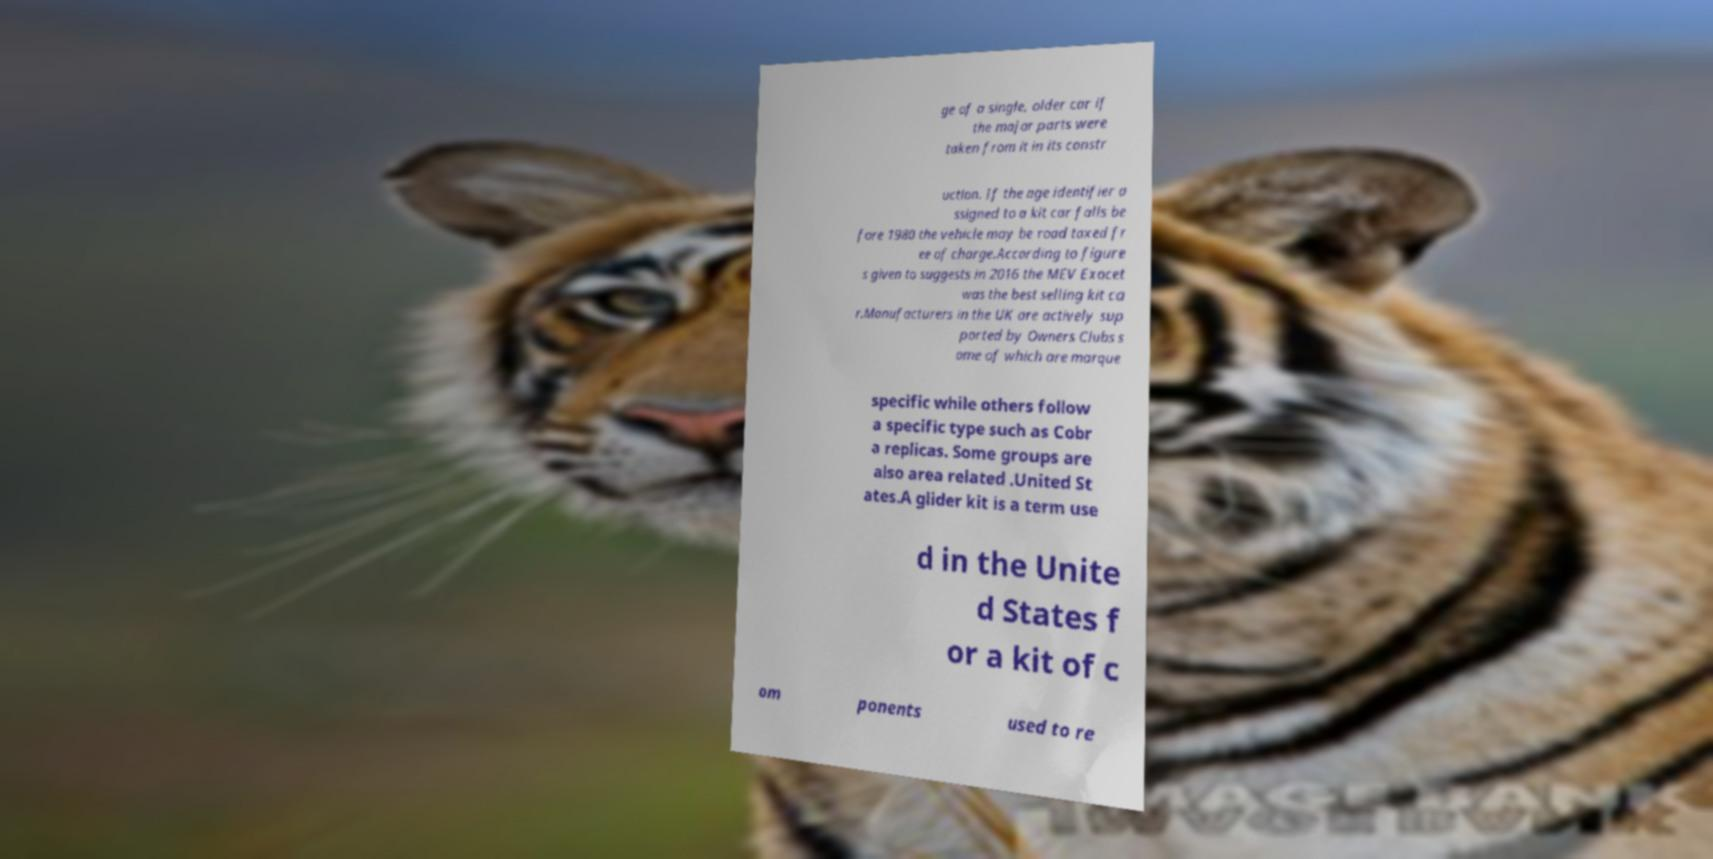What messages or text are displayed in this image? I need them in a readable, typed format. ge of a single, older car if the major parts were taken from it in its constr uction. If the age identifier a ssigned to a kit car falls be fore 1980 the vehicle may be road taxed fr ee of charge.According to figure s given to suggests in 2016 the MEV Exocet was the best selling kit ca r.Manufacturers in the UK are actively sup ported by Owners Clubs s ome of which are marque specific while others follow a specific type such as Cobr a replicas. Some groups are also area related .United St ates.A glider kit is a term use d in the Unite d States f or a kit of c om ponents used to re 